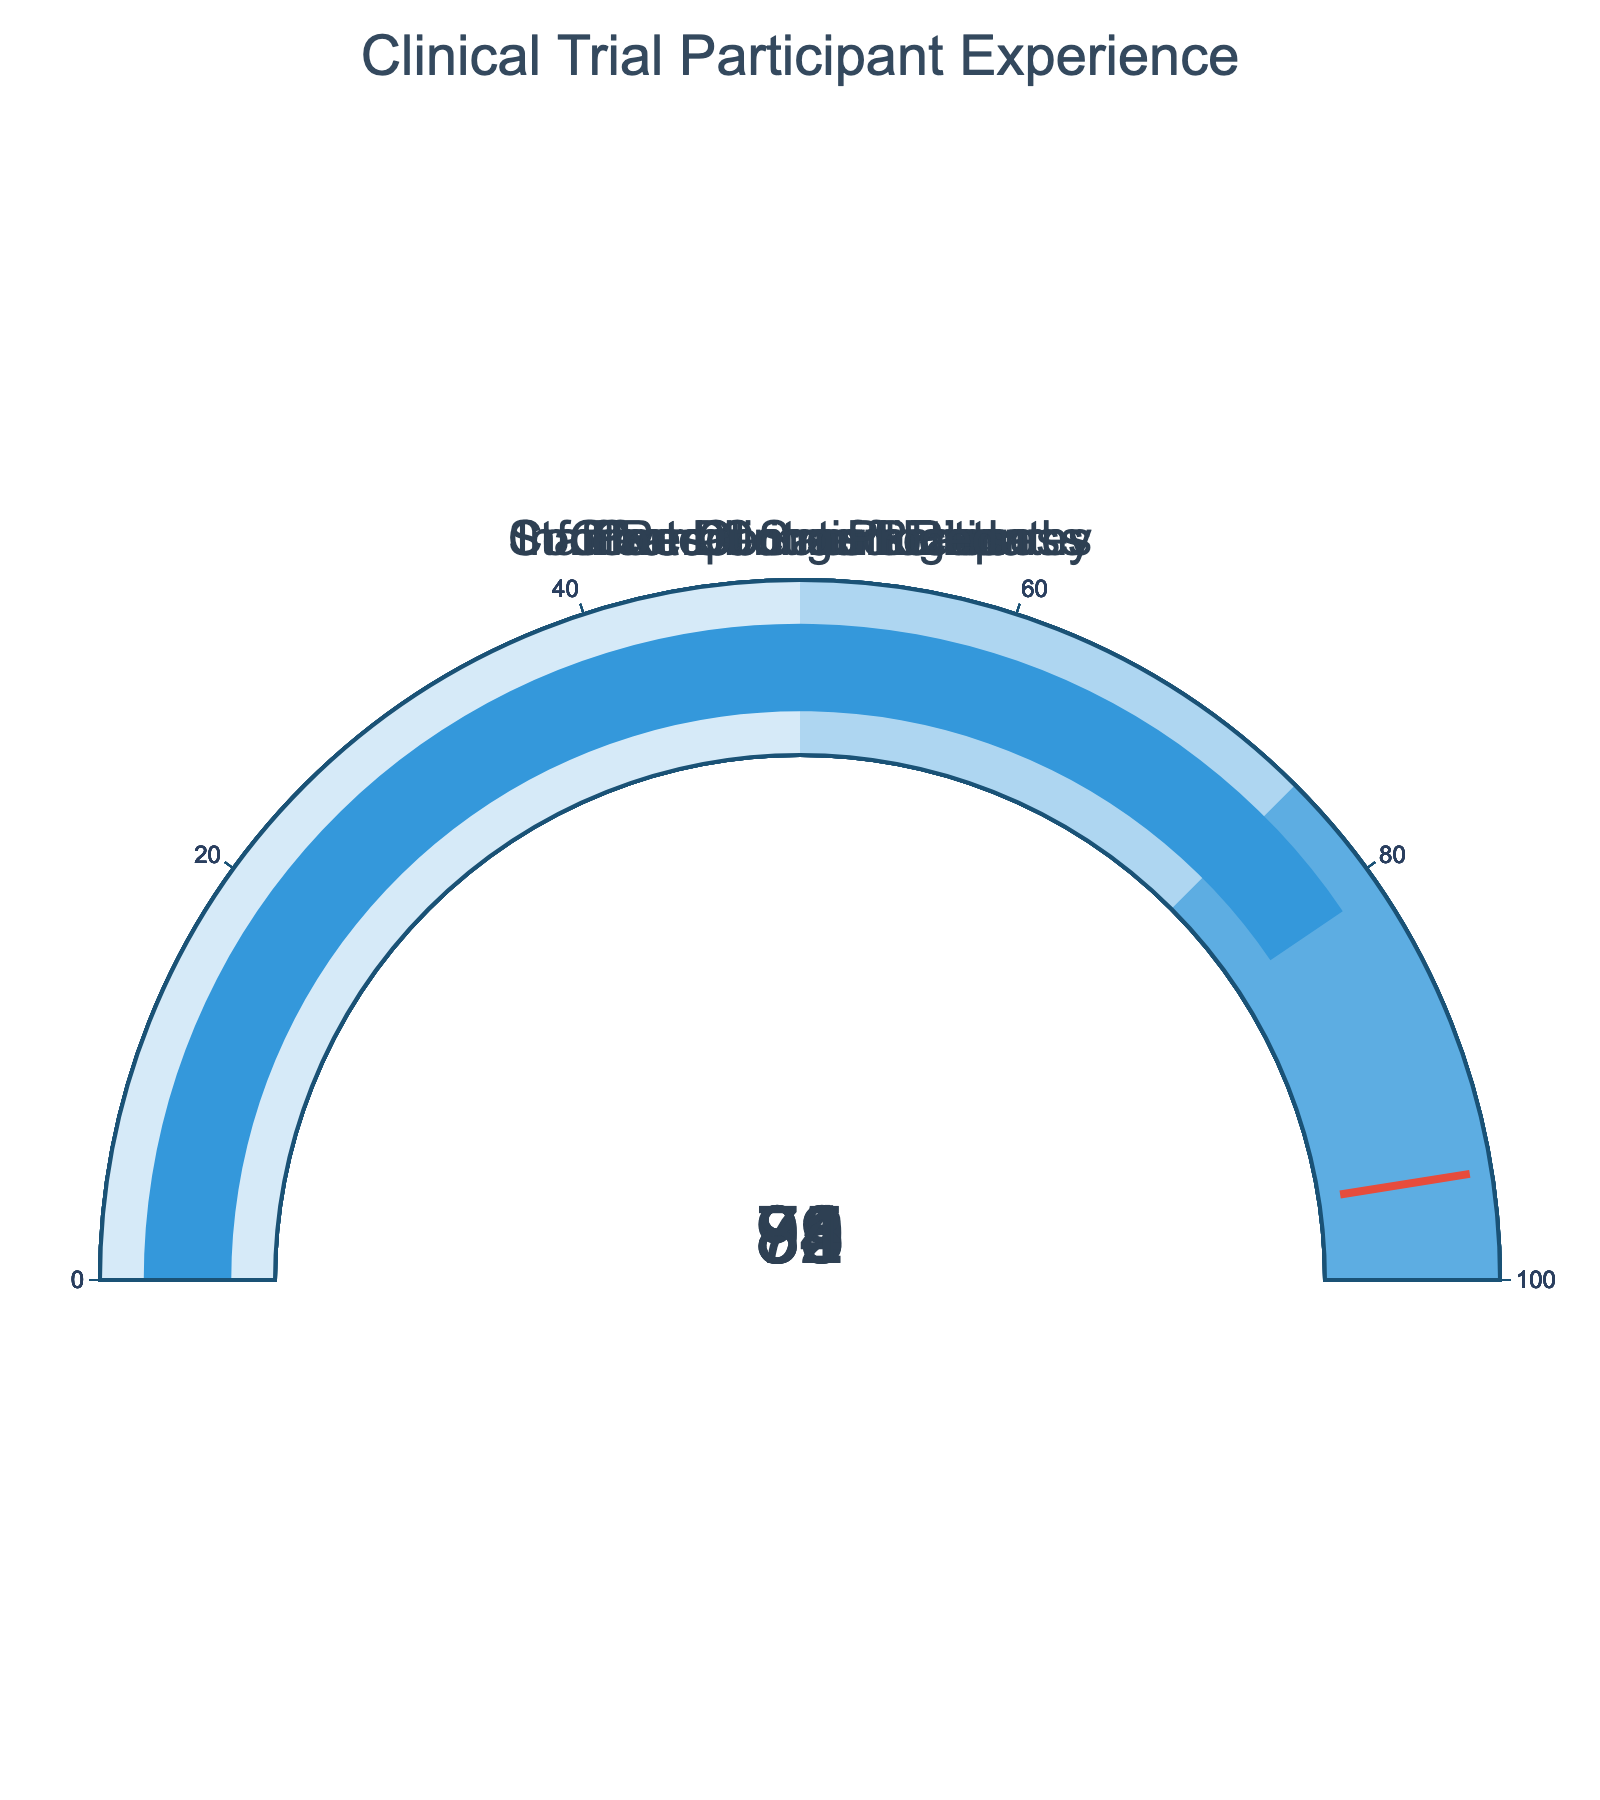What's the title of the plot? The title is typically located at the top of the plot. In this figure, it reads "Clinical Trial Participant Experience".
Answer: Clinical Trial Participant Experience How many categories are presented in the figure? By counting the gauge charts within the figure, you can determine the number of categories. There are six distinct gauge charts, one for each category.
Answer: Six What is the percentage of participants reporting clear communication? Locate the gauge chart labeled "Clear Communication" and note the percentage value displayed. It shows a value of 78%.
Answer: 78% Which category has the highest percentage of positive experiences? Compare all the values displayed in the individual gauges. "Protection of Rights" has the highest value at 94%.
Answer: Protection of Rights What's the average percentage of all categories? To find the average, sum all the percentage values and divide by the number of categories: (85 + 92 + 89 + 78 + 94 + 81) / 6 = 519 / 6 = 86.5
Answer: 86.5 Is the percentage of overall satisfaction greater than comfort during procedures? Compare the percentage values for "Overall Satisfaction" (85%) and "Comfort During Procedures" (81%). 85% is greater than 81%.
Answer: Yes What is the difference in percentage between the categories with the highest and lowest values? First, identify the highest (Protection of Rights at 94%) and lowest (Clear Communication at 78%) values. Subtract the lowest percentage from the highest: 94% - 78% = 16%.
Answer: 16% Which two categories have percentage values closest to each other? Compare the differences between all category values. "Staff Respect and Empathy" (89%) and "Comfort During Procedures" (81%) are 8% apart, which is the smallest difference.
Answer: Staff Respect and Empathy, Comfort During Procedures What is the percentage range covered in the gauges? The range encompasses the minimum and maximum values displayed by the gauges, which are from 78% (Clear Communication) to 94% (Protection of Rights). The full range is 94% - 78% = 16%.
Answer: 16% Are there any categories where the percentage is lower than 80%? Check all gauge charts to see if any values are below 80%. "Clear Communication" shows 78%, which is below 80%.
Answer: Yes 